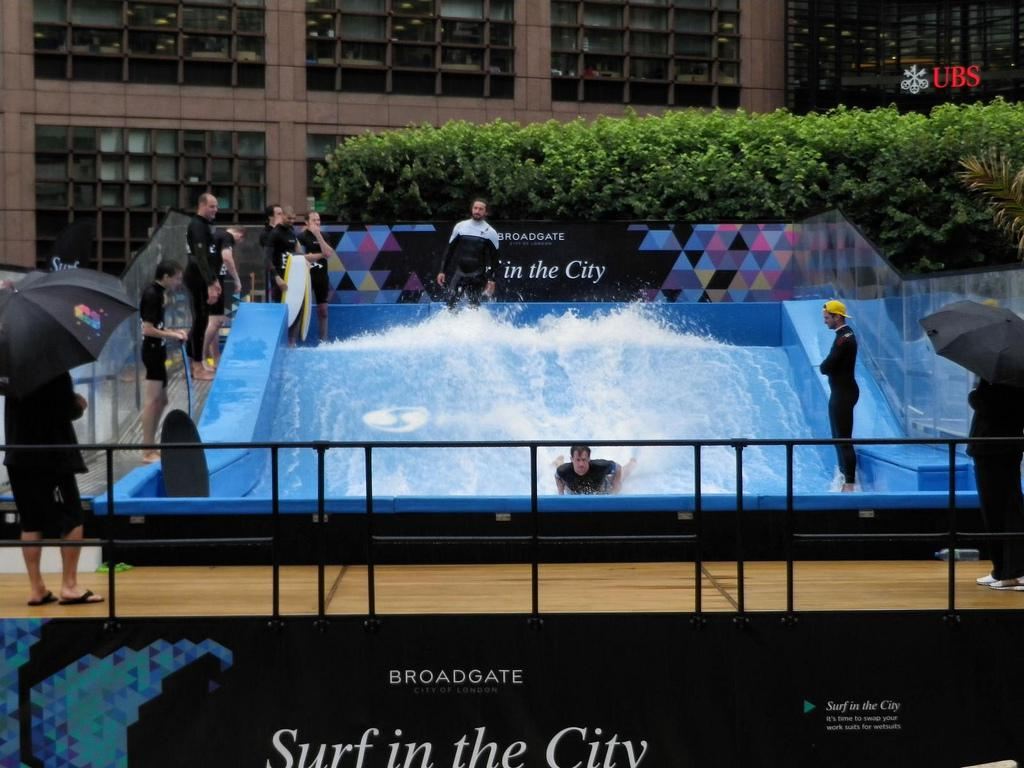Question: what are the surfers doing?
Choices:
A. Practicing.
B. Swimming.
C. Competing.
D. Riding.
Answer with the letter. Answer: A Question: how many people are there?
Choices:
A. Nine.
B. Seven.
C. Ten.
D. Two.
Answer with the letter. Answer: A Question: when are they doing that?
Choices:
A. During study class.
B. During the evening.
C. At night.
D. During the day.
Answer with the letter. Answer: D Question: where is the green hedge?
Choices:
A. In front of the water.
B. Below the water.
C. Behind the artificial wave.
D. Above the water.
Answer with the letter. Answer: C Question: who is holding an umbrella?
Choices:
A. A man.
B. A child.
C. An old man.
D. A woman.
Answer with the letter. Answer: D Question: who is wearing wetsuits?
Choices:
A. The people on the beach.
B. Surfers.
C. Fisherman.
D. Divers.
Answer with the letter. Answer: B Question: what are they doing?
Choices:
A. Riding waves on the water.
B. Playing.
C. Reading.
D. Eating.
Answer with the letter. Answer: A Question: what is in the background?
Choices:
A. A car.
B. A building.
C. An airplane.
D. A tree.
Answer with the letter. Answer: B Question: what is "surf in the city"?
Choices:
A. An urban attraction.
B. A new club.
C. A type of food.
D. A flooded part of town.
Answer with the letter. Answer: A Question: where the photo taken?
Choices:
A. Hospital.
B. From travel trailer.
C. At a surf event.
D. From his helmet.
Answer with the letter. Answer: C Question: where are they at?
Choices:
A. The park.
B. An office building.
C. At a place that makes artificial waves.
D. A conference room.
Answer with the letter. Answer: C Question: who is riding a wakeboard in wave pool?
Choices:
A. A tourist.
B. A surfer.
C. A man.
D. One person.
Answer with the letter. Answer: D Question: where is the surfer wearing the yellow hat?
Choices:
A. In the ocean.
B. On the left.
C. On his surfboard.
D. On the right.
Answer with the letter. Answer: D Question: who owns the attraction?
Choices:
A. Broadgate.
B. An entertainment company.
C. A property company.
D. A wealthy landowner.
Answer with the letter. Answer: A Question: why is he holding an umbrella?
Choices:
A. Because it is raining.
B. To shield the sun.
C. Because he is prepared for anything.
D. As part of a second line at a New Orleans funeral.
Answer with the letter. Answer: B Question: what are they waiting for?
Choices:
A. The right moment.
B. The starting gun.
C. To surf.
D. Something amazing to happen.
Answer with the letter. Answer: C Question: who has flip flops on?
Choices:
A. A woman.
B. A man holding an umbrella.
C. A man.
D. A child.
Answer with the letter. Answer: B 